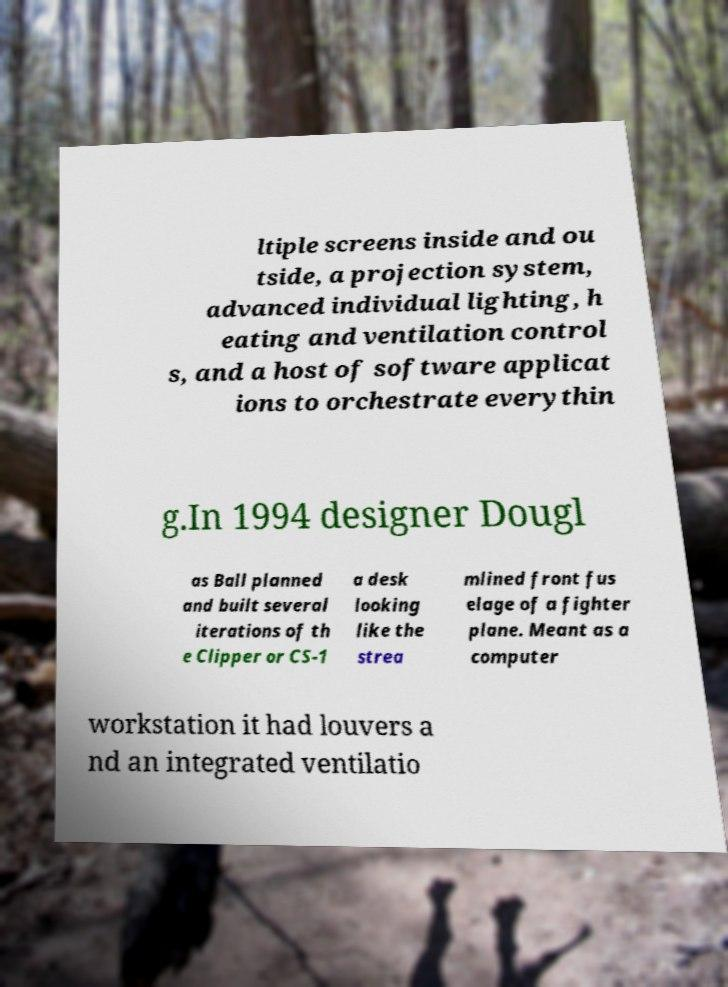Could you extract and type out the text from this image? ltiple screens inside and ou tside, a projection system, advanced individual lighting, h eating and ventilation control s, and a host of software applicat ions to orchestrate everythin g.In 1994 designer Dougl as Ball planned and built several iterations of th e Clipper or CS-1 a desk looking like the strea mlined front fus elage of a fighter plane. Meant as a computer workstation it had louvers a nd an integrated ventilatio 